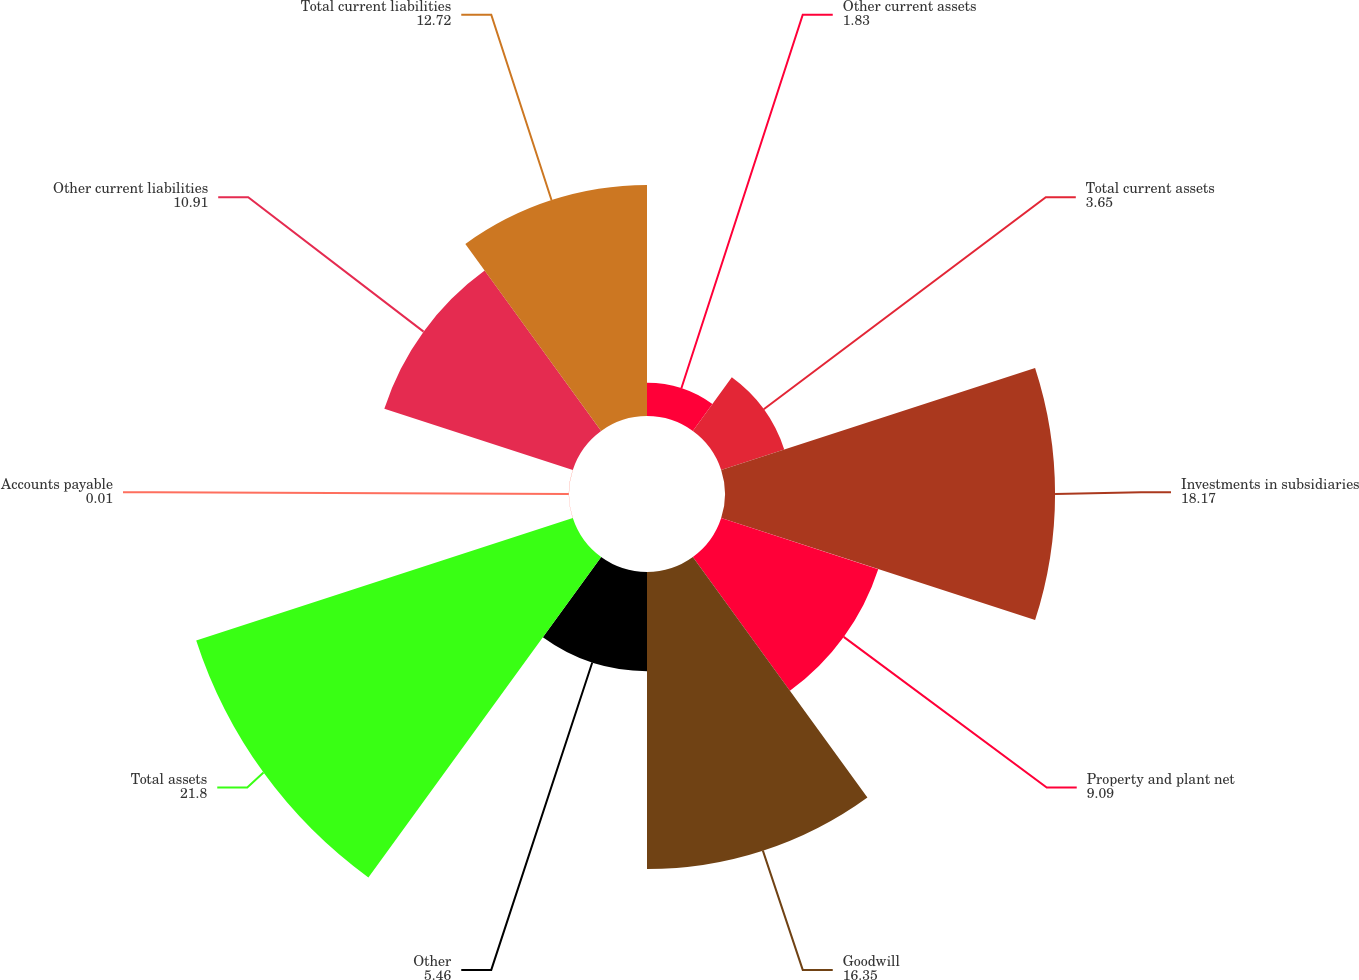Convert chart to OTSL. <chart><loc_0><loc_0><loc_500><loc_500><pie_chart><fcel>Other current assets<fcel>Total current assets<fcel>Investments in subsidiaries<fcel>Property and plant net<fcel>Goodwill<fcel>Other<fcel>Total assets<fcel>Accounts payable<fcel>Other current liabilities<fcel>Total current liabilities<nl><fcel>1.83%<fcel>3.65%<fcel>18.17%<fcel>9.09%<fcel>16.35%<fcel>5.46%<fcel>21.8%<fcel>0.01%<fcel>10.91%<fcel>12.72%<nl></chart> 